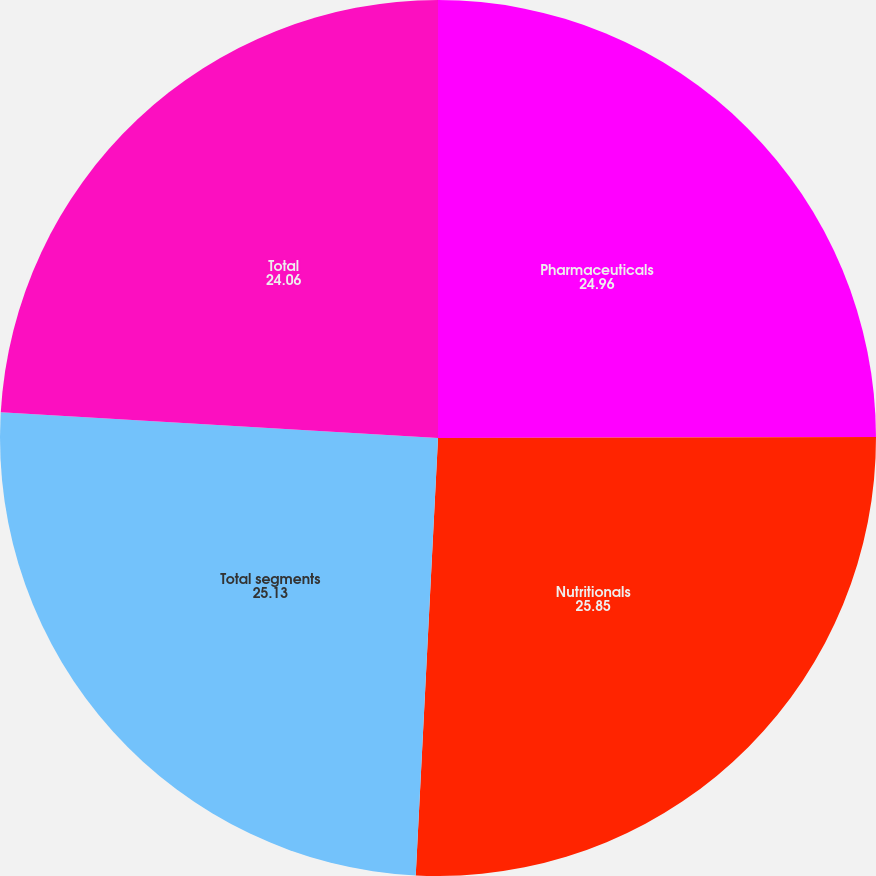<chart> <loc_0><loc_0><loc_500><loc_500><pie_chart><fcel>Pharmaceuticals<fcel>Nutritionals<fcel>Total segments<fcel>Total<nl><fcel>24.96%<fcel>25.85%<fcel>25.13%<fcel>24.06%<nl></chart> 